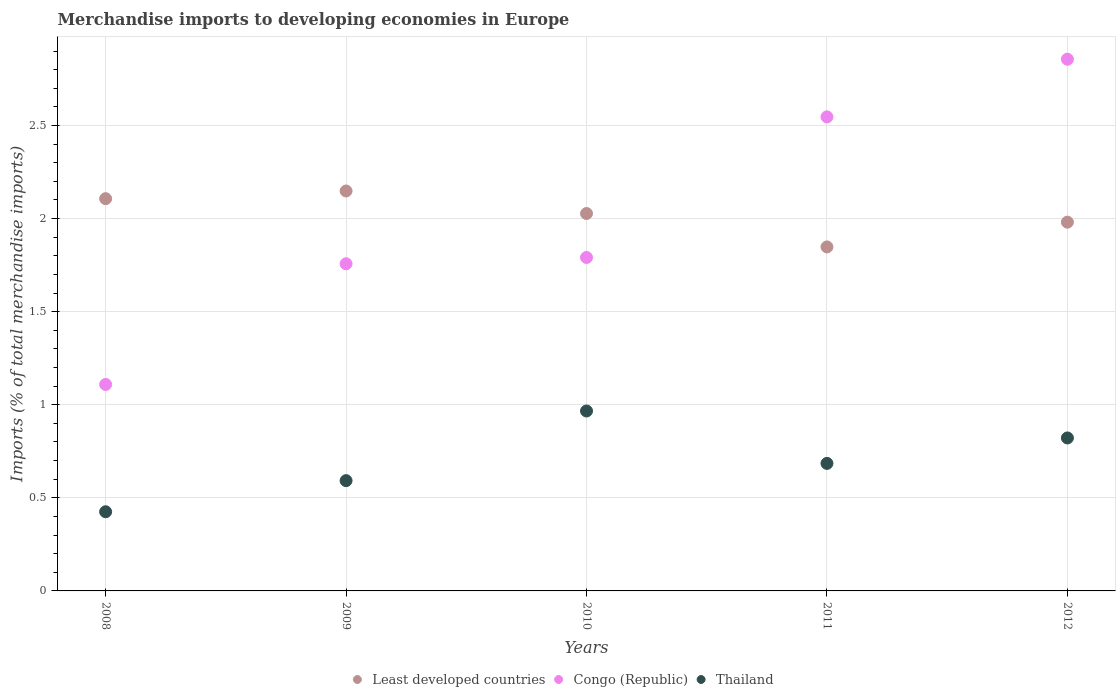Is the number of dotlines equal to the number of legend labels?
Provide a short and direct response. Yes. What is the percentage total merchandise imports in Thailand in 2008?
Offer a terse response. 0.43. Across all years, what is the maximum percentage total merchandise imports in Congo (Republic)?
Your answer should be very brief. 2.86. Across all years, what is the minimum percentage total merchandise imports in Congo (Republic)?
Your answer should be very brief. 1.11. In which year was the percentage total merchandise imports in Least developed countries maximum?
Ensure brevity in your answer.  2009. In which year was the percentage total merchandise imports in Thailand minimum?
Ensure brevity in your answer.  2008. What is the total percentage total merchandise imports in Thailand in the graph?
Keep it short and to the point. 3.49. What is the difference between the percentage total merchandise imports in Congo (Republic) in 2009 and that in 2011?
Ensure brevity in your answer.  -0.79. What is the difference between the percentage total merchandise imports in Least developed countries in 2011 and the percentage total merchandise imports in Thailand in 2010?
Give a very brief answer. 0.88. What is the average percentage total merchandise imports in Least developed countries per year?
Make the answer very short. 2.02. In the year 2009, what is the difference between the percentage total merchandise imports in Congo (Republic) and percentage total merchandise imports in Thailand?
Provide a succinct answer. 1.16. In how many years, is the percentage total merchandise imports in Thailand greater than 0.8 %?
Your answer should be very brief. 2. What is the ratio of the percentage total merchandise imports in Congo (Republic) in 2010 to that in 2012?
Your answer should be very brief. 0.63. What is the difference between the highest and the second highest percentage total merchandise imports in Congo (Republic)?
Make the answer very short. 0.31. What is the difference between the highest and the lowest percentage total merchandise imports in Thailand?
Your answer should be compact. 0.54. Is the percentage total merchandise imports in Least developed countries strictly less than the percentage total merchandise imports in Thailand over the years?
Provide a succinct answer. No. What is the difference between two consecutive major ticks on the Y-axis?
Your response must be concise. 0.5. What is the title of the graph?
Keep it short and to the point. Merchandise imports to developing economies in Europe. Does "Tajikistan" appear as one of the legend labels in the graph?
Offer a terse response. No. What is the label or title of the X-axis?
Provide a short and direct response. Years. What is the label or title of the Y-axis?
Your answer should be very brief. Imports (% of total merchandise imports). What is the Imports (% of total merchandise imports) of Least developed countries in 2008?
Keep it short and to the point. 2.11. What is the Imports (% of total merchandise imports) of Congo (Republic) in 2008?
Your response must be concise. 1.11. What is the Imports (% of total merchandise imports) in Thailand in 2008?
Ensure brevity in your answer.  0.43. What is the Imports (% of total merchandise imports) of Least developed countries in 2009?
Make the answer very short. 2.15. What is the Imports (% of total merchandise imports) of Congo (Republic) in 2009?
Your answer should be very brief. 1.76. What is the Imports (% of total merchandise imports) of Thailand in 2009?
Provide a short and direct response. 0.59. What is the Imports (% of total merchandise imports) of Least developed countries in 2010?
Offer a very short reply. 2.03. What is the Imports (% of total merchandise imports) in Congo (Republic) in 2010?
Make the answer very short. 1.79. What is the Imports (% of total merchandise imports) in Thailand in 2010?
Your answer should be compact. 0.97. What is the Imports (% of total merchandise imports) in Least developed countries in 2011?
Provide a succinct answer. 1.85. What is the Imports (% of total merchandise imports) in Congo (Republic) in 2011?
Your response must be concise. 2.55. What is the Imports (% of total merchandise imports) in Thailand in 2011?
Offer a very short reply. 0.68. What is the Imports (% of total merchandise imports) of Least developed countries in 2012?
Provide a short and direct response. 1.98. What is the Imports (% of total merchandise imports) in Congo (Republic) in 2012?
Give a very brief answer. 2.86. What is the Imports (% of total merchandise imports) of Thailand in 2012?
Offer a very short reply. 0.82. Across all years, what is the maximum Imports (% of total merchandise imports) in Least developed countries?
Provide a succinct answer. 2.15. Across all years, what is the maximum Imports (% of total merchandise imports) of Congo (Republic)?
Provide a succinct answer. 2.86. Across all years, what is the maximum Imports (% of total merchandise imports) in Thailand?
Your response must be concise. 0.97. Across all years, what is the minimum Imports (% of total merchandise imports) in Least developed countries?
Your response must be concise. 1.85. Across all years, what is the minimum Imports (% of total merchandise imports) in Congo (Republic)?
Make the answer very short. 1.11. Across all years, what is the minimum Imports (% of total merchandise imports) of Thailand?
Your answer should be very brief. 0.43. What is the total Imports (% of total merchandise imports) of Least developed countries in the graph?
Offer a terse response. 10.11. What is the total Imports (% of total merchandise imports) of Congo (Republic) in the graph?
Give a very brief answer. 10.06. What is the total Imports (% of total merchandise imports) in Thailand in the graph?
Your response must be concise. 3.49. What is the difference between the Imports (% of total merchandise imports) of Least developed countries in 2008 and that in 2009?
Give a very brief answer. -0.04. What is the difference between the Imports (% of total merchandise imports) of Congo (Republic) in 2008 and that in 2009?
Offer a terse response. -0.65. What is the difference between the Imports (% of total merchandise imports) in Thailand in 2008 and that in 2009?
Offer a terse response. -0.17. What is the difference between the Imports (% of total merchandise imports) of Least developed countries in 2008 and that in 2010?
Your answer should be very brief. 0.08. What is the difference between the Imports (% of total merchandise imports) in Congo (Republic) in 2008 and that in 2010?
Provide a succinct answer. -0.68. What is the difference between the Imports (% of total merchandise imports) in Thailand in 2008 and that in 2010?
Provide a succinct answer. -0.54. What is the difference between the Imports (% of total merchandise imports) of Least developed countries in 2008 and that in 2011?
Your answer should be compact. 0.26. What is the difference between the Imports (% of total merchandise imports) in Congo (Republic) in 2008 and that in 2011?
Provide a short and direct response. -1.44. What is the difference between the Imports (% of total merchandise imports) of Thailand in 2008 and that in 2011?
Ensure brevity in your answer.  -0.26. What is the difference between the Imports (% of total merchandise imports) of Least developed countries in 2008 and that in 2012?
Your answer should be compact. 0.13. What is the difference between the Imports (% of total merchandise imports) of Congo (Republic) in 2008 and that in 2012?
Provide a short and direct response. -1.75. What is the difference between the Imports (% of total merchandise imports) in Thailand in 2008 and that in 2012?
Your response must be concise. -0.4. What is the difference between the Imports (% of total merchandise imports) in Least developed countries in 2009 and that in 2010?
Keep it short and to the point. 0.12. What is the difference between the Imports (% of total merchandise imports) of Congo (Republic) in 2009 and that in 2010?
Ensure brevity in your answer.  -0.03. What is the difference between the Imports (% of total merchandise imports) of Thailand in 2009 and that in 2010?
Your answer should be compact. -0.37. What is the difference between the Imports (% of total merchandise imports) of Least developed countries in 2009 and that in 2011?
Ensure brevity in your answer.  0.3. What is the difference between the Imports (% of total merchandise imports) in Congo (Republic) in 2009 and that in 2011?
Your answer should be very brief. -0.79. What is the difference between the Imports (% of total merchandise imports) in Thailand in 2009 and that in 2011?
Provide a short and direct response. -0.09. What is the difference between the Imports (% of total merchandise imports) in Least developed countries in 2009 and that in 2012?
Make the answer very short. 0.17. What is the difference between the Imports (% of total merchandise imports) of Congo (Republic) in 2009 and that in 2012?
Your response must be concise. -1.1. What is the difference between the Imports (% of total merchandise imports) of Thailand in 2009 and that in 2012?
Your answer should be very brief. -0.23. What is the difference between the Imports (% of total merchandise imports) in Least developed countries in 2010 and that in 2011?
Your response must be concise. 0.18. What is the difference between the Imports (% of total merchandise imports) in Congo (Republic) in 2010 and that in 2011?
Ensure brevity in your answer.  -0.76. What is the difference between the Imports (% of total merchandise imports) of Thailand in 2010 and that in 2011?
Your answer should be compact. 0.28. What is the difference between the Imports (% of total merchandise imports) of Least developed countries in 2010 and that in 2012?
Ensure brevity in your answer.  0.05. What is the difference between the Imports (% of total merchandise imports) of Congo (Republic) in 2010 and that in 2012?
Offer a terse response. -1.06. What is the difference between the Imports (% of total merchandise imports) in Thailand in 2010 and that in 2012?
Your answer should be very brief. 0.14. What is the difference between the Imports (% of total merchandise imports) in Least developed countries in 2011 and that in 2012?
Ensure brevity in your answer.  -0.13. What is the difference between the Imports (% of total merchandise imports) in Congo (Republic) in 2011 and that in 2012?
Provide a succinct answer. -0.31. What is the difference between the Imports (% of total merchandise imports) of Thailand in 2011 and that in 2012?
Ensure brevity in your answer.  -0.14. What is the difference between the Imports (% of total merchandise imports) in Least developed countries in 2008 and the Imports (% of total merchandise imports) in Congo (Republic) in 2009?
Give a very brief answer. 0.35. What is the difference between the Imports (% of total merchandise imports) of Least developed countries in 2008 and the Imports (% of total merchandise imports) of Thailand in 2009?
Offer a very short reply. 1.51. What is the difference between the Imports (% of total merchandise imports) of Congo (Republic) in 2008 and the Imports (% of total merchandise imports) of Thailand in 2009?
Your answer should be very brief. 0.52. What is the difference between the Imports (% of total merchandise imports) in Least developed countries in 2008 and the Imports (% of total merchandise imports) in Congo (Republic) in 2010?
Your answer should be compact. 0.32. What is the difference between the Imports (% of total merchandise imports) of Least developed countries in 2008 and the Imports (% of total merchandise imports) of Thailand in 2010?
Your response must be concise. 1.14. What is the difference between the Imports (% of total merchandise imports) of Congo (Republic) in 2008 and the Imports (% of total merchandise imports) of Thailand in 2010?
Offer a terse response. 0.14. What is the difference between the Imports (% of total merchandise imports) in Least developed countries in 2008 and the Imports (% of total merchandise imports) in Congo (Republic) in 2011?
Offer a terse response. -0.44. What is the difference between the Imports (% of total merchandise imports) in Least developed countries in 2008 and the Imports (% of total merchandise imports) in Thailand in 2011?
Your response must be concise. 1.42. What is the difference between the Imports (% of total merchandise imports) of Congo (Republic) in 2008 and the Imports (% of total merchandise imports) of Thailand in 2011?
Provide a succinct answer. 0.42. What is the difference between the Imports (% of total merchandise imports) in Least developed countries in 2008 and the Imports (% of total merchandise imports) in Congo (Republic) in 2012?
Offer a terse response. -0.75. What is the difference between the Imports (% of total merchandise imports) in Least developed countries in 2008 and the Imports (% of total merchandise imports) in Thailand in 2012?
Give a very brief answer. 1.29. What is the difference between the Imports (% of total merchandise imports) of Congo (Republic) in 2008 and the Imports (% of total merchandise imports) of Thailand in 2012?
Make the answer very short. 0.29. What is the difference between the Imports (% of total merchandise imports) in Least developed countries in 2009 and the Imports (% of total merchandise imports) in Congo (Republic) in 2010?
Your response must be concise. 0.36. What is the difference between the Imports (% of total merchandise imports) of Least developed countries in 2009 and the Imports (% of total merchandise imports) of Thailand in 2010?
Your answer should be very brief. 1.18. What is the difference between the Imports (% of total merchandise imports) of Congo (Republic) in 2009 and the Imports (% of total merchandise imports) of Thailand in 2010?
Offer a terse response. 0.79. What is the difference between the Imports (% of total merchandise imports) in Least developed countries in 2009 and the Imports (% of total merchandise imports) in Congo (Republic) in 2011?
Give a very brief answer. -0.4. What is the difference between the Imports (% of total merchandise imports) in Least developed countries in 2009 and the Imports (% of total merchandise imports) in Thailand in 2011?
Keep it short and to the point. 1.46. What is the difference between the Imports (% of total merchandise imports) of Congo (Republic) in 2009 and the Imports (% of total merchandise imports) of Thailand in 2011?
Your response must be concise. 1.07. What is the difference between the Imports (% of total merchandise imports) of Least developed countries in 2009 and the Imports (% of total merchandise imports) of Congo (Republic) in 2012?
Your response must be concise. -0.71. What is the difference between the Imports (% of total merchandise imports) of Least developed countries in 2009 and the Imports (% of total merchandise imports) of Thailand in 2012?
Your answer should be very brief. 1.33. What is the difference between the Imports (% of total merchandise imports) in Congo (Republic) in 2009 and the Imports (% of total merchandise imports) in Thailand in 2012?
Give a very brief answer. 0.94. What is the difference between the Imports (% of total merchandise imports) of Least developed countries in 2010 and the Imports (% of total merchandise imports) of Congo (Republic) in 2011?
Keep it short and to the point. -0.52. What is the difference between the Imports (% of total merchandise imports) of Least developed countries in 2010 and the Imports (% of total merchandise imports) of Thailand in 2011?
Your answer should be very brief. 1.34. What is the difference between the Imports (% of total merchandise imports) of Congo (Republic) in 2010 and the Imports (% of total merchandise imports) of Thailand in 2011?
Ensure brevity in your answer.  1.11. What is the difference between the Imports (% of total merchandise imports) in Least developed countries in 2010 and the Imports (% of total merchandise imports) in Congo (Republic) in 2012?
Offer a terse response. -0.83. What is the difference between the Imports (% of total merchandise imports) of Least developed countries in 2010 and the Imports (% of total merchandise imports) of Thailand in 2012?
Ensure brevity in your answer.  1.21. What is the difference between the Imports (% of total merchandise imports) of Congo (Republic) in 2010 and the Imports (% of total merchandise imports) of Thailand in 2012?
Provide a short and direct response. 0.97. What is the difference between the Imports (% of total merchandise imports) of Least developed countries in 2011 and the Imports (% of total merchandise imports) of Congo (Republic) in 2012?
Give a very brief answer. -1.01. What is the difference between the Imports (% of total merchandise imports) in Congo (Republic) in 2011 and the Imports (% of total merchandise imports) in Thailand in 2012?
Offer a terse response. 1.72. What is the average Imports (% of total merchandise imports) of Least developed countries per year?
Keep it short and to the point. 2.02. What is the average Imports (% of total merchandise imports) of Congo (Republic) per year?
Your answer should be compact. 2.01. What is the average Imports (% of total merchandise imports) of Thailand per year?
Make the answer very short. 0.7. In the year 2008, what is the difference between the Imports (% of total merchandise imports) of Least developed countries and Imports (% of total merchandise imports) of Congo (Republic)?
Offer a very short reply. 1. In the year 2008, what is the difference between the Imports (% of total merchandise imports) in Least developed countries and Imports (% of total merchandise imports) in Thailand?
Your answer should be compact. 1.68. In the year 2008, what is the difference between the Imports (% of total merchandise imports) of Congo (Republic) and Imports (% of total merchandise imports) of Thailand?
Offer a very short reply. 0.68. In the year 2009, what is the difference between the Imports (% of total merchandise imports) in Least developed countries and Imports (% of total merchandise imports) in Congo (Republic)?
Give a very brief answer. 0.39. In the year 2009, what is the difference between the Imports (% of total merchandise imports) of Least developed countries and Imports (% of total merchandise imports) of Thailand?
Give a very brief answer. 1.56. In the year 2009, what is the difference between the Imports (% of total merchandise imports) of Congo (Republic) and Imports (% of total merchandise imports) of Thailand?
Offer a very short reply. 1.16. In the year 2010, what is the difference between the Imports (% of total merchandise imports) in Least developed countries and Imports (% of total merchandise imports) in Congo (Republic)?
Your answer should be compact. 0.24. In the year 2010, what is the difference between the Imports (% of total merchandise imports) in Least developed countries and Imports (% of total merchandise imports) in Thailand?
Your answer should be very brief. 1.06. In the year 2010, what is the difference between the Imports (% of total merchandise imports) of Congo (Republic) and Imports (% of total merchandise imports) of Thailand?
Keep it short and to the point. 0.82. In the year 2011, what is the difference between the Imports (% of total merchandise imports) of Least developed countries and Imports (% of total merchandise imports) of Congo (Republic)?
Make the answer very short. -0.7. In the year 2011, what is the difference between the Imports (% of total merchandise imports) in Least developed countries and Imports (% of total merchandise imports) in Thailand?
Offer a terse response. 1.16. In the year 2011, what is the difference between the Imports (% of total merchandise imports) in Congo (Republic) and Imports (% of total merchandise imports) in Thailand?
Make the answer very short. 1.86. In the year 2012, what is the difference between the Imports (% of total merchandise imports) in Least developed countries and Imports (% of total merchandise imports) in Congo (Republic)?
Offer a terse response. -0.88. In the year 2012, what is the difference between the Imports (% of total merchandise imports) of Least developed countries and Imports (% of total merchandise imports) of Thailand?
Your response must be concise. 1.16. In the year 2012, what is the difference between the Imports (% of total merchandise imports) of Congo (Republic) and Imports (% of total merchandise imports) of Thailand?
Provide a succinct answer. 2.03. What is the ratio of the Imports (% of total merchandise imports) of Least developed countries in 2008 to that in 2009?
Your answer should be compact. 0.98. What is the ratio of the Imports (% of total merchandise imports) in Congo (Republic) in 2008 to that in 2009?
Ensure brevity in your answer.  0.63. What is the ratio of the Imports (% of total merchandise imports) in Thailand in 2008 to that in 2009?
Provide a short and direct response. 0.72. What is the ratio of the Imports (% of total merchandise imports) of Least developed countries in 2008 to that in 2010?
Your answer should be compact. 1.04. What is the ratio of the Imports (% of total merchandise imports) of Congo (Republic) in 2008 to that in 2010?
Offer a very short reply. 0.62. What is the ratio of the Imports (% of total merchandise imports) in Thailand in 2008 to that in 2010?
Your response must be concise. 0.44. What is the ratio of the Imports (% of total merchandise imports) in Least developed countries in 2008 to that in 2011?
Your answer should be compact. 1.14. What is the ratio of the Imports (% of total merchandise imports) of Congo (Republic) in 2008 to that in 2011?
Offer a very short reply. 0.44. What is the ratio of the Imports (% of total merchandise imports) in Thailand in 2008 to that in 2011?
Provide a short and direct response. 0.62. What is the ratio of the Imports (% of total merchandise imports) of Least developed countries in 2008 to that in 2012?
Offer a very short reply. 1.06. What is the ratio of the Imports (% of total merchandise imports) of Congo (Republic) in 2008 to that in 2012?
Ensure brevity in your answer.  0.39. What is the ratio of the Imports (% of total merchandise imports) in Thailand in 2008 to that in 2012?
Ensure brevity in your answer.  0.52. What is the ratio of the Imports (% of total merchandise imports) in Least developed countries in 2009 to that in 2010?
Your answer should be compact. 1.06. What is the ratio of the Imports (% of total merchandise imports) of Congo (Republic) in 2009 to that in 2010?
Ensure brevity in your answer.  0.98. What is the ratio of the Imports (% of total merchandise imports) of Thailand in 2009 to that in 2010?
Offer a very short reply. 0.61. What is the ratio of the Imports (% of total merchandise imports) in Least developed countries in 2009 to that in 2011?
Your answer should be very brief. 1.16. What is the ratio of the Imports (% of total merchandise imports) of Congo (Republic) in 2009 to that in 2011?
Keep it short and to the point. 0.69. What is the ratio of the Imports (% of total merchandise imports) in Thailand in 2009 to that in 2011?
Offer a terse response. 0.86. What is the ratio of the Imports (% of total merchandise imports) of Least developed countries in 2009 to that in 2012?
Your answer should be very brief. 1.08. What is the ratio of the Imports (% of total merchandise imports) of Congo (Republic) in 2009 to that in 2012?
Make the answer very short. 0.62. What is the ratio of the Imports (% of total merchandise imports) in Thailand in 2009 to that in 2012?
Your response must be concise. 0.72. What is the ratio of the Imports (% of total merchandise imports) in Least developed countries in 2010 to that in 2011?
Provide a short and direct response. 1.1. What is the ratio of the Imports (% of total merchandise imports) of Congo (Republic) in 2010 to that in 2011?
Provide a short and direct response. 0.7. What is the ratio of the Imports (% of total merchandise imports) of Thailand in 2010 to that in 2011?
Your response must be concise. 1.41. What is the ratio of the Imports (% of total merchandise imports) in Least developed countries in 2010 to that in 2012?
Make the answer very short. 1.02. What is the ratio of the Imports (% of total merchandise imports) of Congo (Republic) in 2010 to that in 2012?
Make the answer very short. 0.63. What is the ratio of the Imports (% of total merchandise imports) in Thailand in 2010 to that in 2012?
Offer a very short reply. 1.18. What is the ratio of the Imports (% of total merchandise imports) in Least developed countries in 2011 to that in 2012?
Offer a very short reply. 0.93. What is the ratio of the Imports (% of total merchandise imports) in Congo (Republic) in 2011 to that in 2012?
Your answer should be compact. 0.89. What is the ratio of the Imports (% of total merchandise imports) of Thailand in 2011 to that in 2012?
Ensure brevity in your answer.  0.83. What is the difference between the highest and the second highest Imports (% of total merchandise imports) in Least developed countries?
Your response must be concise. 0.04. What is the difference between the highest and the second highest Imports (% of total merchandise imports) of Congo (Republic)?
Make the answer very short. 0.31. What is the difference between the highest and the second highest Imports (% of total merchandise imports) in Thailand?
Your answer should be very brief. 0.14. What is the difference between the highest and the lowest Imports (% of total merchandise imports) of Least developed countries?
Your response must be concise. 0.3. What is the difference between the highest and the lowest Imports (% of total merchandise imports) in Congo (Republic)?
Offer a terse response. 1.75. What is the difference between the highest and the lowest Imports (% of total merchandise imports) of Thailand?
Provide a succinct answer. 0.54. 